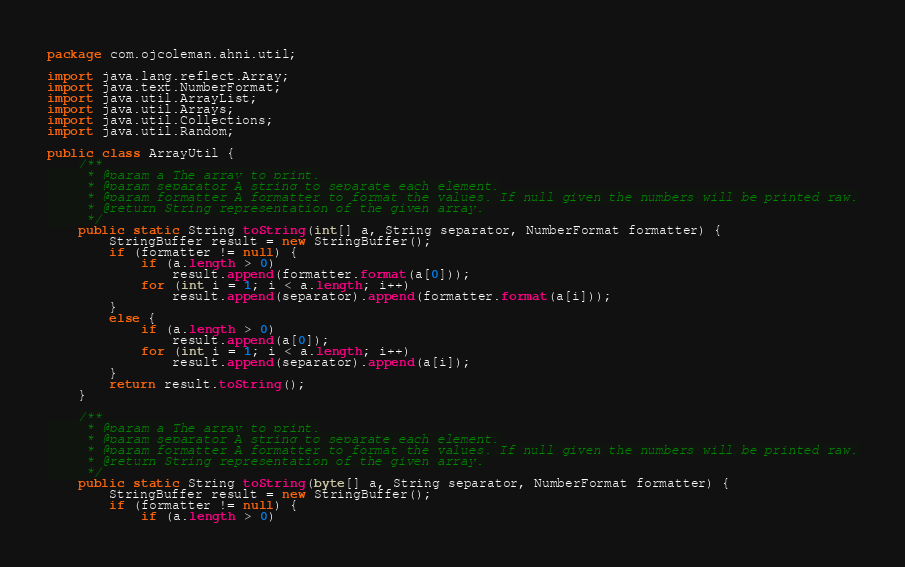Convert code to text. <code><loc_0><loc_0><loc_500><loc_500><_Java_>package com.ojcoleman.ahni.util;

import java.lang.reflect.Array;
import java.text.NumberFormat;
import java.util.ArrayList;
import java.util.Arrays;
import java.util.Collections;
import java.util.Random;

public class ArrayUtil {
	/**
	 * @param a The array to print.
	 * @param separator A string to separate each element.
	 * @param formatter A formatter to format the values. If null given the numbers will be printed raw.
	 * @return String representation of the given array.
	 */
	public static String toString(int[] a, String separator, NumberFormat formatter) {
		StringBuffer result = new StringBuffer();
		if (formatter != null) {
			if (a.length > 0)
				result.append(formatter.format(a[0]));
			for (int i = 1; i < a.length; i++)
				result.append(separator).append(formatter.format(a[i]));
		}
		else {
			if (a.length > 0)
				result.append(a[0]);
			for (int i = 1; i < a.length; i++)
				result.append(separator).append(a[i]);
		}
		return result.toString();
	}
	
	/**
	 * @param a The array to print.
	 * @param separator A string to separate each element.
	 * @param formatter A formatter to format the values. If null given the numbers will be printed raw.
	 * @return String representation of the given array.
	 */
	public static String toString(byte[] a, String separator, NumberFormat formatter) {
		StringBuffer result = new StringBuffer();
		if (formatter != null) {
			if (a.length > 0)</code> 